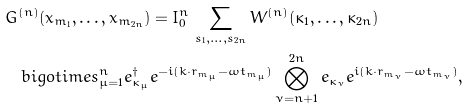Convert formula to latex. <formula><loc_0><loc_0><loc_500><loc_500>& G ^ { ( n ) } ( x _ { m _ { 1 } } , \dots , x _ { m _ { 2 n } } ) = I _ { 0 } ^ { n } \, \sum _ { s _ { 1 } , \dots , s _ { 2 n } } W ^ { ( n ) } ( \kappa _ { 1 } , \dots , \kappa _ { 2 n } ) \\ & \quad b i g o t i m e s _ { \mu = 1 } ^ { n } e _ { \kappa _ { \mu } } ^ { \dagger } e ^ { - i ( k \cdot r _ { m _ { \mu } } - \omega t _ { m _ { \mu } } ) } \bigotimes _ { \nu = n + 1 } ^ { 2 n } e _ { \kappa _ { \nu } } e ^ { i ( k \cdot r _ { m _ { \nu } } - \omega t _ { m _ { \nu } } ) } ,</formula> 